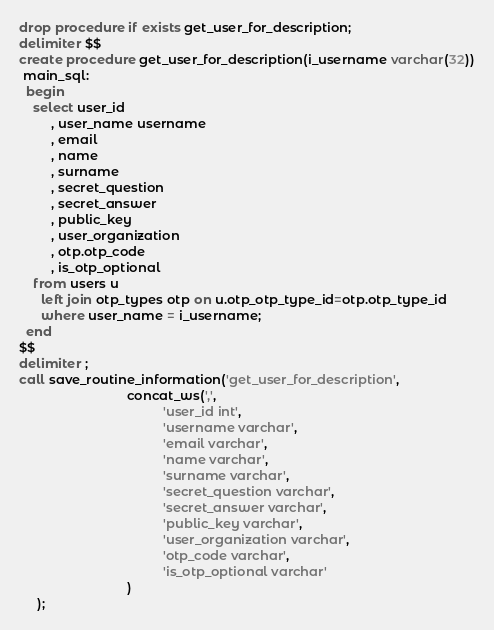Convert code to text. <code><loc_0><loc_0><loc_500><loc_500><_SQL_>drop procedure if exists get_user_for_description;
delimiter $$
create procedure get_user_for_description(i_username varchar(32))
 main_sql:
  begin
    select user_id
         , user_name username
         , email
         , name
         , surname
         , secret_question
         , secret_answer
         , public_key
         , user_organization
         , otp.otp_code
         , is_otp_optional
    from users u
      left join otp_types otp on u.otp_otp_type_id=otp.otp_type_id
      where user_name = i_username;
  end                                                    
$$
delimiter ;
call save_routine_information('get_user_for_description',
                              concat_ws(',',
                                        'user_id int',
                                        'username varchar',
                                        'email varchar',
                                        'name varchar',
                                        'surname varchar',
                                        'secret_question varchar',
                                        'secret_answer varchar',
					                    'public_key varchar',
                                        'user_organization varchar',
                                        'otp_code varchar',
                                        'is_otp_optional varchar'
                              )
     );</code> 